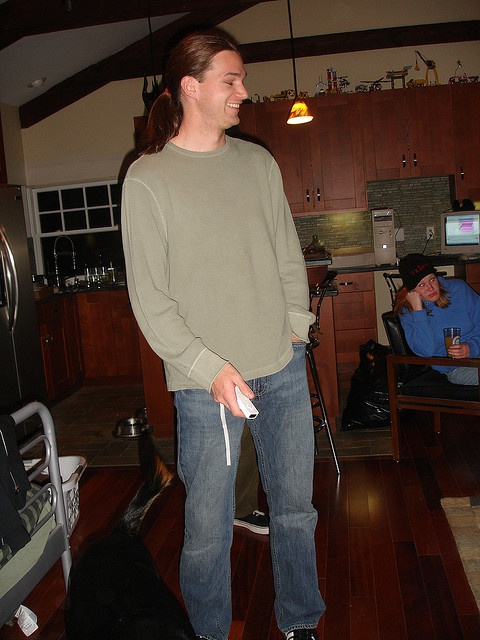Describe the objects in this image and their specific colors. I can see people in black, darkgray, and gray tones, dog in black, maroon, and gray tones, people in black, darkblue, navy, and maroon tones, refrigerator in black, gray, and maroon tones, and chair in black, gray, navy, and darkblue tones in this image. 